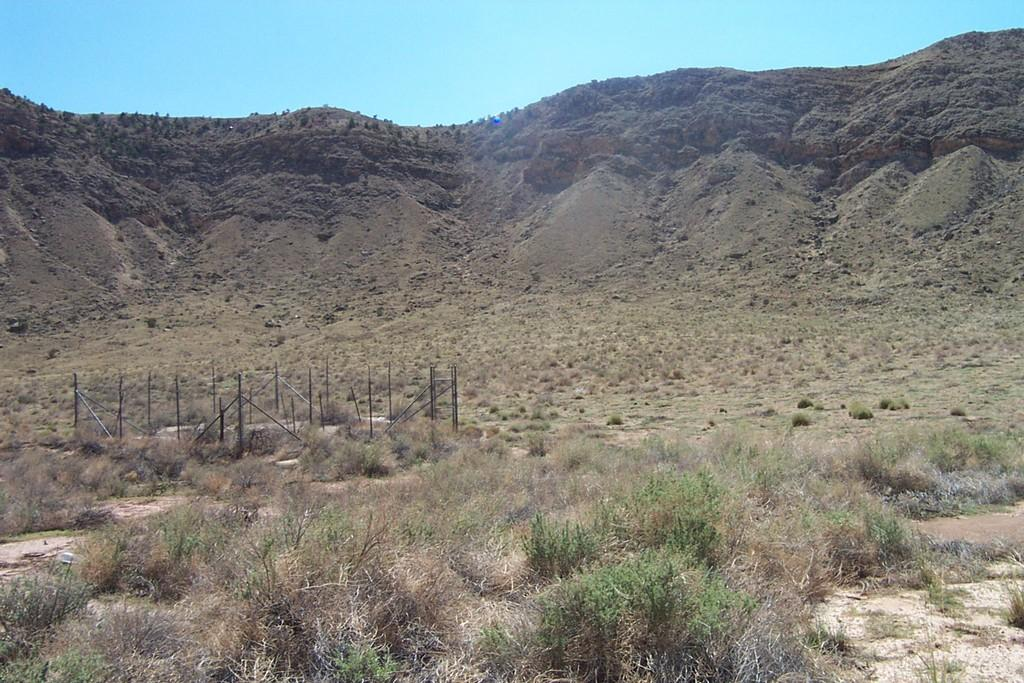What type of landscape is depicted in the image? The image features hills. What type of vegetation can be seen at the bottom of the image? There is grass at the bottom of the image. What structure is present at the bottom of the image? There is a fence at the bottom of the image. How many letters are being blown by the wind in the image? There are no letters present in the image, and therefore no letters can be blown by the wind. 